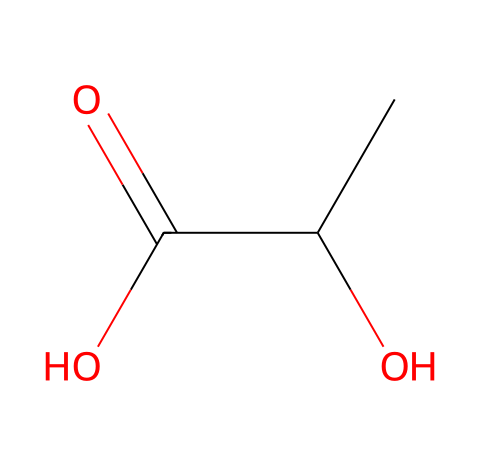What is the name of this chemical? The provided SMILES representation corresponds to a compound known as lactic acid, which is a key building block for polylactic acid (PLA).
Answer: lactic acid How many carbon atoms are present in this structure? Upon analyzing the SMILES, there are two carbon atoms indicated by the "CC" at the beginning, where "C" represents carbon.
Answer: 2 What is the total number of oxygen atoms in this molecule? The SMILES shows two "O" notations, indicating that there are two oxygen atoms present in the structure.
Answer: 2 Which functional groups are present in this chemical? The structure contains a hydroxyl group (-OH) and a carboxylic acid group (-COOH), which are represented by "O" and "C(=O)O" portions of the SMILES.
Answer: hydroxyl and carboxylic acid How does this chemical relate to polymer production? Lactic acid is a monomer that polymerizes to form polylactic acid (PLA), a biodegradable polymer commonly used in eco-friendly 3D printing filaments.
Answer: monomer for PLA What is the molecular formula of this compound? From the SMILES, we identify 2 carbon atoms, 6 hydrogen atoms, and 2 oxygen atoms, leading to the molecular formula C3H6O3 for lactic acid.
Answer: C3H6O3 What type of polymer is derived from this chemical? Lactic acid is primarily used to produce polylactic acid (PLA), which is a type of biodegradable aliphatic polyester.
Answer: biodegradable polyester 